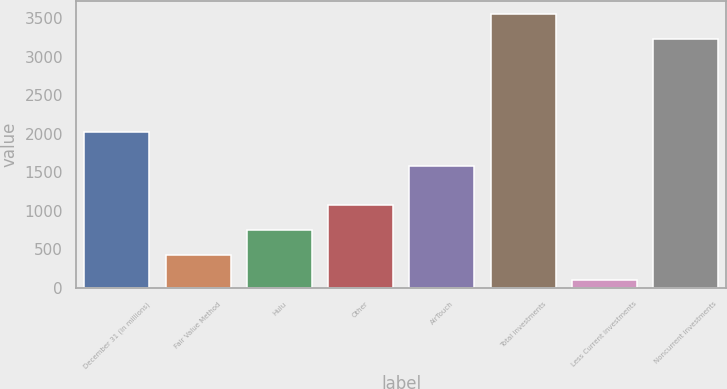<chart> <loc_0><loc_0><loc_500><loc_500><bar_chart><fcel>December 31 (in millions)<fcel>Fair Value Method<fcel>Hulu<fcel>Other<fcel>AirTouch<fcel>Total investments<fcel>Less Current investments<fcel>Noncurrent investments<nl><fcel>2015<fcel>428.4<fcel>750.8<fcel>1073.2<fcel>1583<fcel>3546.4<fcel>106<fcel>3224<nl></chart> 